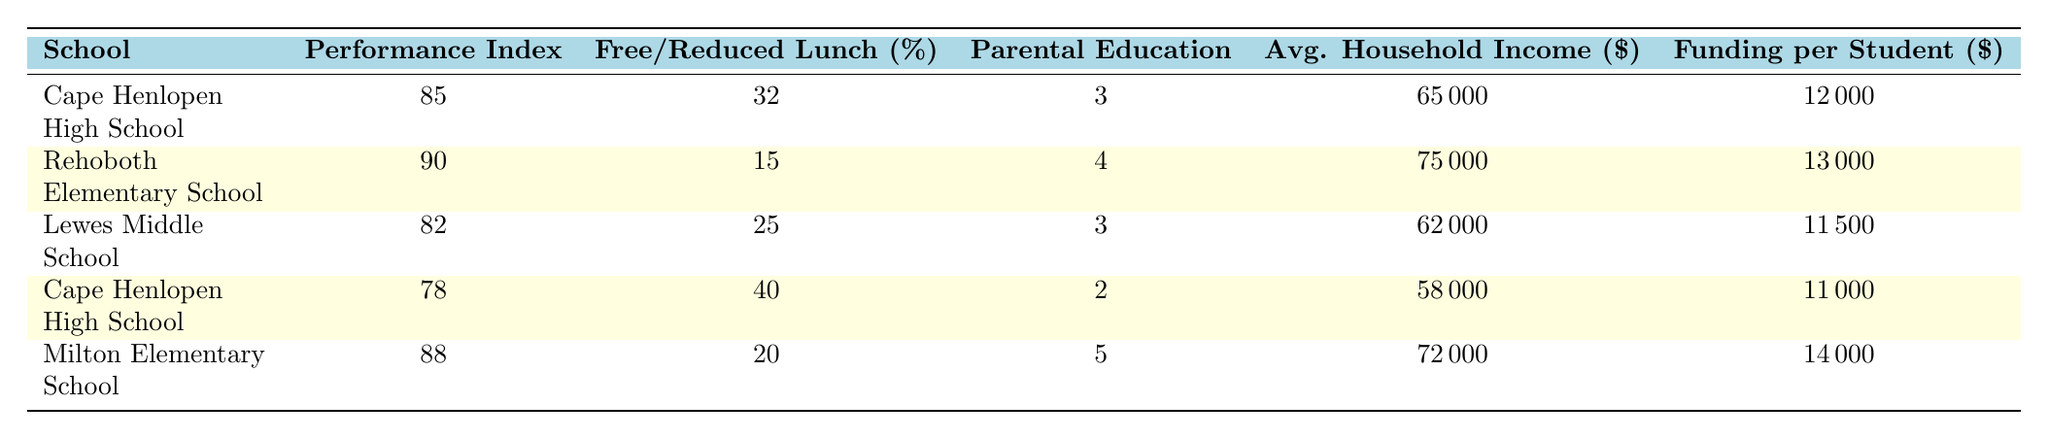What is the performance index of Rehoboth Elementary School? The table lists the performance index of Rehoboth Elementary School as 90.
Answer: 90 Which school has the highest average household income? Comparing the average household incomes listed, Rehoboth Elementary School has the highest at 75000.
Answer: Rehoboth Elementary School What is the free/reduced lunch percentage at Milton Elementary School? The table shows that the free/reduced lunch percentage at Milton Elementary School is 20.
Answer: 20 Is the parental education level at Cape Henlopen High School higher or lower than that at Lewes Middle School? Cape Henlopen High School has a parental education level of 3, while Lewes Middle School also has a parental education level of 3, indicating they are equal.
Answer: Equal What is the difference in student performance index between Cape Henlopen High School and Milton Elementary School? The performance index for Cape Henlopen High School is 85, and for Milton Elementary School is 88. The difference is 88 - 85 = 3.
Answer: 3 What is the average free/reduced lunch percentage across all the schools? Adding the free/reduced lunch percentages (32 + 15 + 25 + 40 + 20 = 132) gives a total of 132. There are 5 schools, so the average is 132 / 5 = 26.4.
Answer: 26.4 Does Lewes Middle School have a higher or lower funding per student compared to Rehoboth Elementary School? Lewes Middle School has a funding per student of 11500, while Rehoboth Elementary School has 13000. Thus, Lewes Middle School has lower funding per student.
Answer: Lower What school has the lowest student performance index? The student performance index for Cape Henlopen High School is 78 in one of its entries, which is lower than the other schools listed, making it the lowest index.
Answer: Cape Henlopen High School What is the average parental education level for all schools listed? Summing the parental education levels (3 + 4 + 3 + 2 + 5 = 17) gives a total of 17, divided by 5 schools tallies to an average of 3.4.
Answer: 3.4 